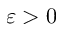<formula> <loc_0><loc_0><loc_500><loc_500>\varepsilon > 0</formula> 